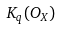Convert formula to latex. <formula><loc_0><loc_0><loc_500><loc_500>K _ { q } ( O _ { X } )</formula> 